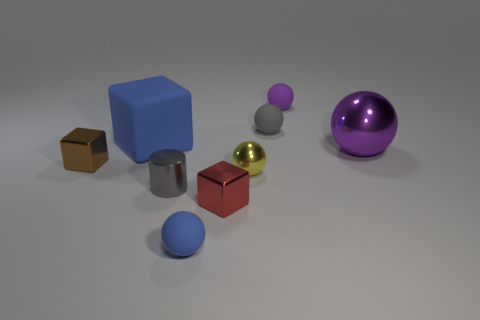Subtract 2 spheres. How many spheres are left? 3 Subtract all purple spheres. How many spheres are left? 3 Subtract all gray rubber spheres. How many spheres are left? 4 Subtract all green balls. Subtract all purple cylinders. How many balls are left? 5 Add 5 tiny brown cubes. How many tiny brown cubes exist? 6 Subtract 0 yellow cubes. How many objects are left? 9 Subtract all cubes. How many objects are left? 6 Subtract all tiny brown matte objects. Subtract all gray rubber things. How many objects are left? 8 Add 3 yellow metal objects. How many yellow metal objects are left? 4 